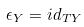<formula> <loc_0><loc_0><loc_500><loc_500>\epsilon _ { Y } = i d _ { T Y }</formula> 